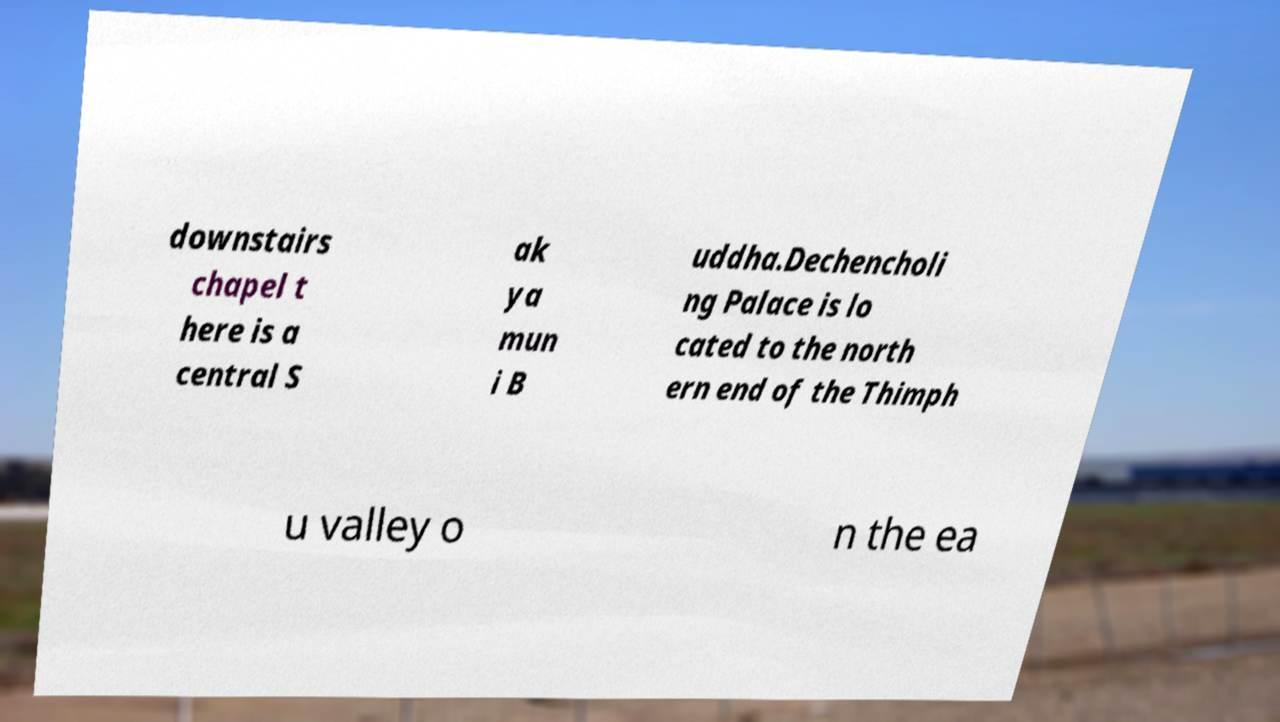I need the written content from this picture converted into text. Can you do that? downstairs chapel t here is a central S ak ya mun i B uddha.Dechencholi ng Palace is lo cated to the north ern end of the Thimph u valley o n the ea 